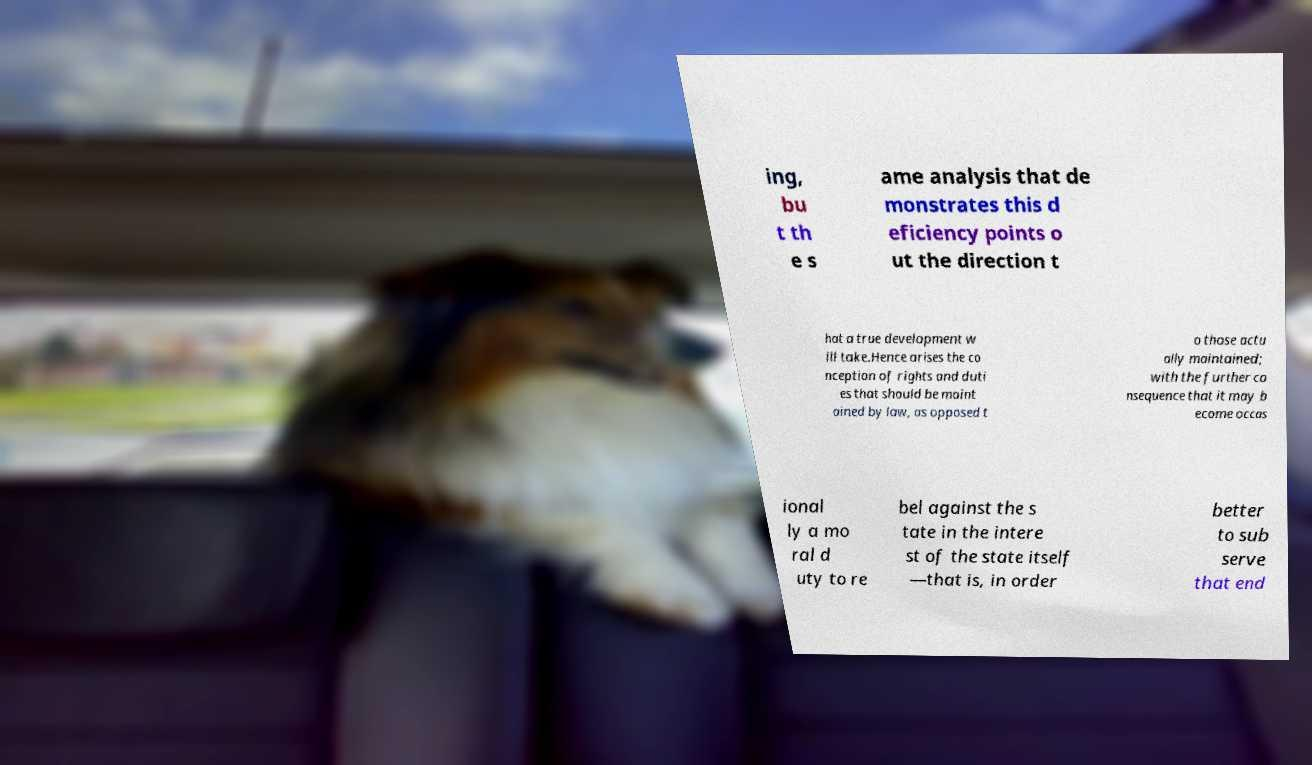Can you accurately transcribe the text from the provided image for me? ing, bu t th e s ame analysis that de monstrates this d eficiency points o ut the direction t hat a true development w ill take.Hence arises the co nception of rights and duti es that should be maint ained by law, as opposed t o those actu ally maintained; with the further co nsequence that it may b ecome occas ional ly a mo ral d uty to re bel against the s tate in the intere st of the state itself —that is, in order better to sub serve that end 